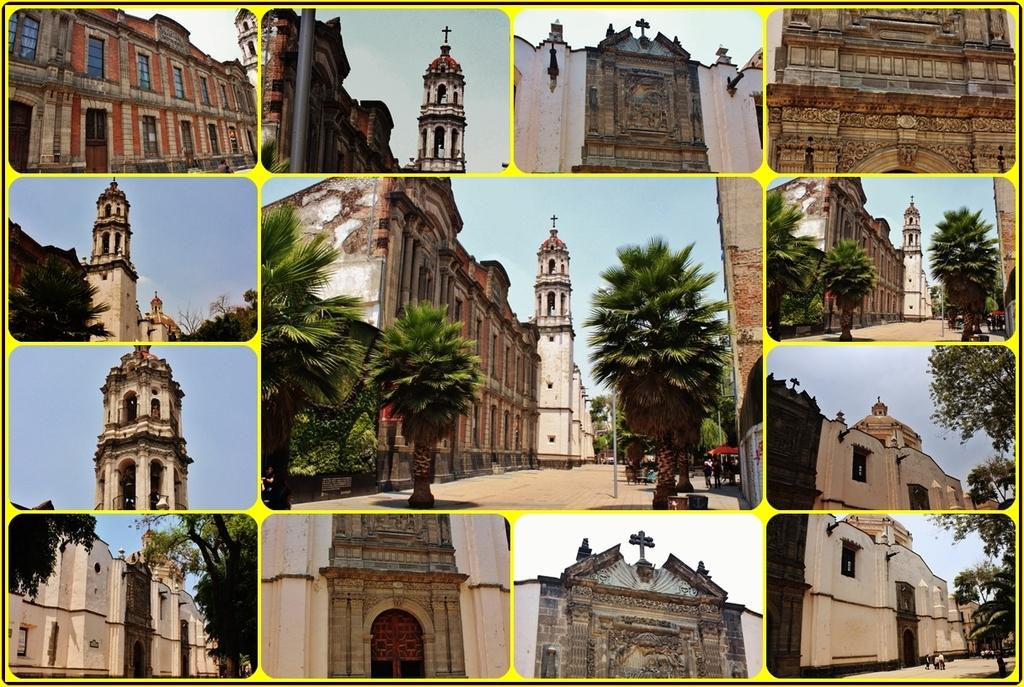What types of structures are depicted in the collage? The collage contains images of churches. What natural elements are included in the collage? The collage contains images of trees. What part of the environment is visible in the collage? The collage contains images of the sky. What type of toy can be seen in the collage? There is no toy present in the collage; it contains images of churches, trees, and the sky. How does the collage affect the acoustics of the room it is displayed in? The collage itself does not affect the acoustics of the room; it is a visual art piece made up of images. 